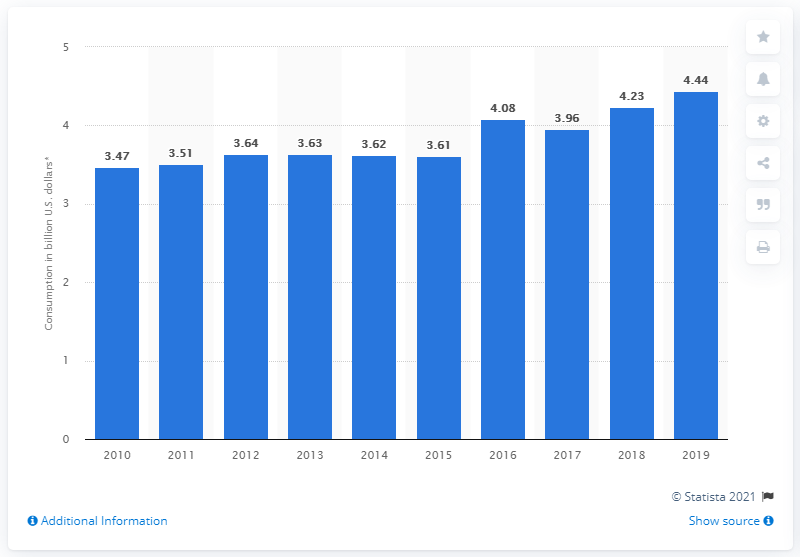Specify some key components in this picture. According to data released in 2019, the Bahamas spent 4.44 billion U.S. dollars on travel and tourism. 